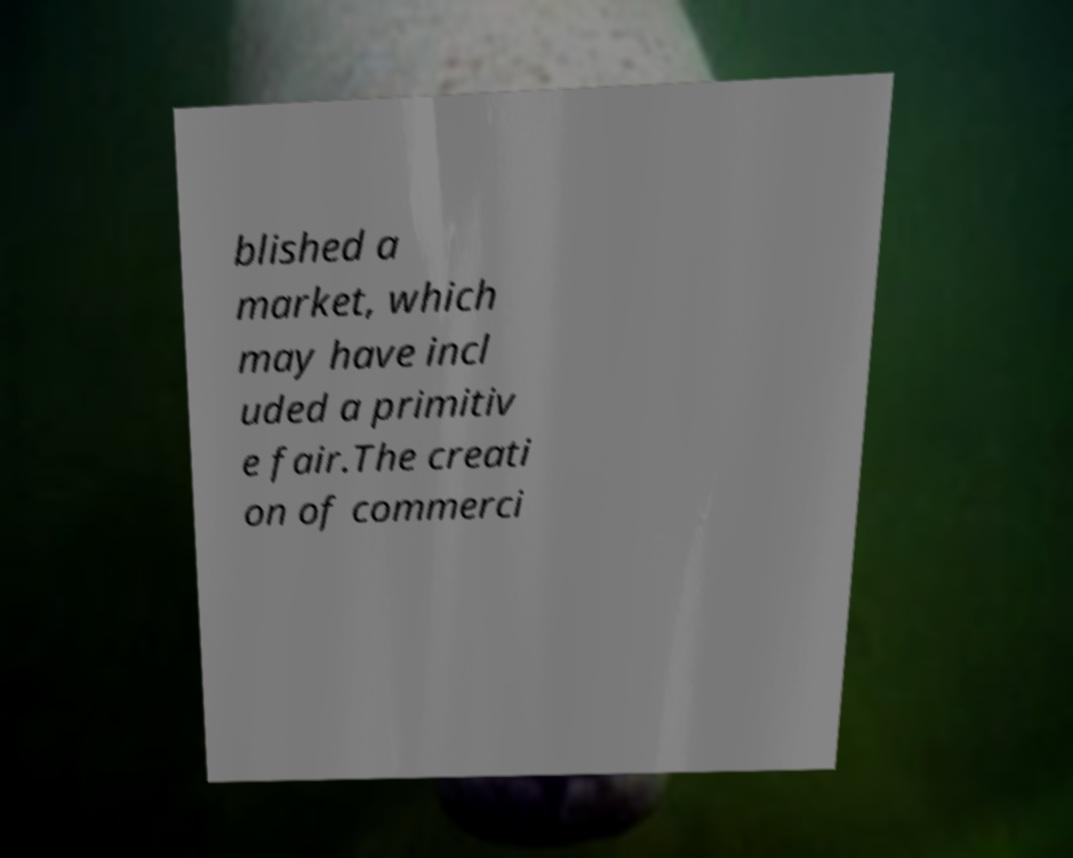Could you extract and type out the text from this image? blished a market, which may have incl uded a primitiv e fair.The creati on of commerci 